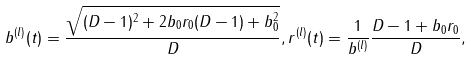<formula> <loc_0><loc_0><loc_500><loc_500>b ^ { ( l ) } ( t ) = \frac { \sqrt { ( D - 1 ) ^ { 2 } + 2 b _ { 0 } r _ { 0 } ( D - 1 ) + b _ { 0 } ^ { 2 } } } { D } , r ^ { ( l ) } ( t ) = \frac { 1 } { b ^ { ( l ) } } \frac { D - 1 + b _ { 0 } r _ { 0 } } { D } ,</formula> 